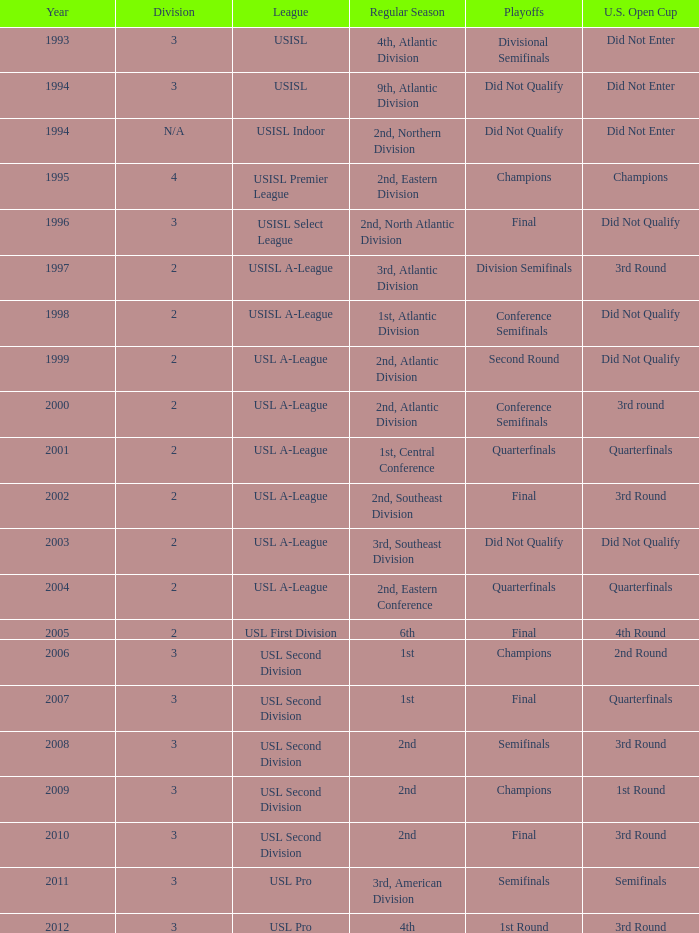Could you parse the entire table as a dict? {'header': ['Year', 'Division', 'League', 'Regular Season', 'Playoffs', 'U.S. Open Cup'], 'rows': [['1993', '3', 'USISL', '4th, Atlantic Division', 'Divisional Semifinals', 'Did Not Enter'], ['1994', '3', 'USISL', '9th, Atlantic Division', 'Did Not Qualify', 'Did Not Enter'], ['1994', 'N/A', 'USISL Indoor', '2nd, Northern Division', 'Did Not Qualify', 'Did Not Enter'], ['1995', '4', 'USISL Premier League', '2nd, Eastern Division', 'Champions', 'Champions'], ['1996', '3', 'USISL Select League', '2nd, North Atlantic Division', 'Final', 'Did Not Qualify'], ['1997', '2', 'USISL A-League', '3rd, Atlantic Division', 'Division Semifinals', '3rd Round'], ['1998', '2', 'USISL A-League', '1st, Atlantic Division', 'Conference Semifinals', 'Did Not Qualify'], ['1999', '2', 'USL A-League', '2nd, Atlantic Division', 'Second Round', 'Did Not Qualify'], ['2000', '2', 'USL A-League', '2nd, Atlantic Division', 'Conference Semifinals', '3rd round'], ['2001', '2', 'USL A-League', '1st, Central Conference', 'Quarterfinals', 'Quarterfinals'], ['2002', '2', 'USL A-League', '2nd, Southeast Division', 'Final', '3rd Round'], ['2003', '2', 'USL A-League', '3rd, Southeast Division', 'Did Not Qualify', 'Did Not Qualify'], ['2004', '2', 'USL A-League', '2nd, Eastern Conference', 'Quarterfinals', 'Quarterfinals'], ['2005', '2', 'USL First Division', '6th', 'Final', '4th Round'], ['2006', '3', 'USL Second Division', '1st', 'Champions', '2nd Round'], ['2007', '3', 'USL Second Division', '1st', 'Final', 'Quarterfinals'], ['2008', '3', 'USL Second Division', '2nd', 'Semifinals', '3rd Round'], ['2009', '3', 'USL Second Division', '2nd', 'Champions', '1st Round'], ['2010', '3', 'USL Second Division', '2nd', 'Final', '3rd Round'], ['2011', '3', 'USL Pro', '3rd, American Division', 'Semifinals', 'Semifinals'], ['2012', '3', 'USL Pro', '4th', '1st Round', '3rd Round']]} How many divisions failed to qualify for the u.s. open cup in 2003? 2.0. 